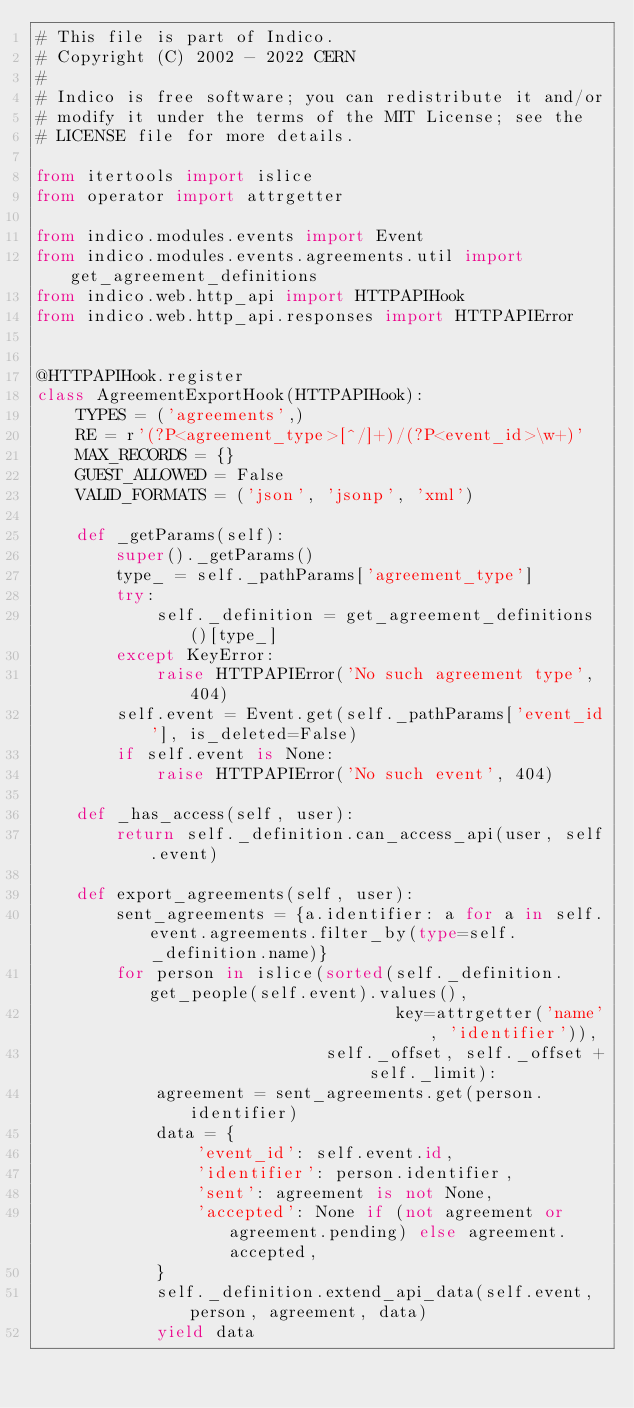Convert code to text. <code><loc_0><loc_0><loc_500><loc_500><_Python_># This file is part of Indico.
# Copyright (C) 2002 - 2022 CERN
#
# Indico is free software; you can redistribute it and/or
# modify it under the terms of the MIT License; see the
# LICENSE file for more details.

from itertools import islice
from operator import attrgetter

from indico.modules.events import Event
from indico.modules.events.agreements.util import get_agreement_definitions
from indico.web.http_api import HTTPAPIHook
from indico.web.http_api.responses import HTTPAPIError


@HTTPAPIHook.register
class AgreementExportHook(HTTPAPIHook):
    TYPES = ('agreements',)
    RE = r'(?P<agreement_type>[^/]+)/(?P<event_id>\w+)'
    MAX_RECORDS = {}
    GUEST_ALLOWED = False
    VALID_FORMATS = ('json', 'jsonp', 'xml')

    def _getParams(self):
        super()._getParams()
        type_ = self._pathParams['agreement_type']
        try:
            self._definition = get_agreement_definitions()[type_]
        except KeyError:
            raise HTTPAPIError('No such agreement type', 404)
        self.event = Event.get(self._pathParams['event_id'], is_deleted=False)
        if self.event is None:
            raise HTTPAPIError('No such event', 404)

    def _has_access(self, user):
        return self._definition.can_access_api(user, self.event)

    def export_agreements(self, user):
        sent_agreements = {a.identifier: a for a in self.event.agreements.filter_by(type=self._definition.name)}
        for person in islice(sorted(self._definition.get_people(self.event).values(),
                                    key=attrgetter('name', 'identifier')),
                             self._offset, self._offset + self._limit):
            agreement = sent_agreements.get(person.identifier)
            data = {
                'event_id': self.event.id,
                'identifier': person.identifier,
                'sent': agreement is not None,
                'accepted': None if (not agreement or agreement.pending) else agreement.accepted,
            }
            self._definition.extend_api_data(self.event, person, agreement, data)
            yield data
</code> 